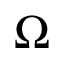Convert formula to latex. <formula><loc_0><loc_0><loc_500><loc_500>\Omega</formula> 